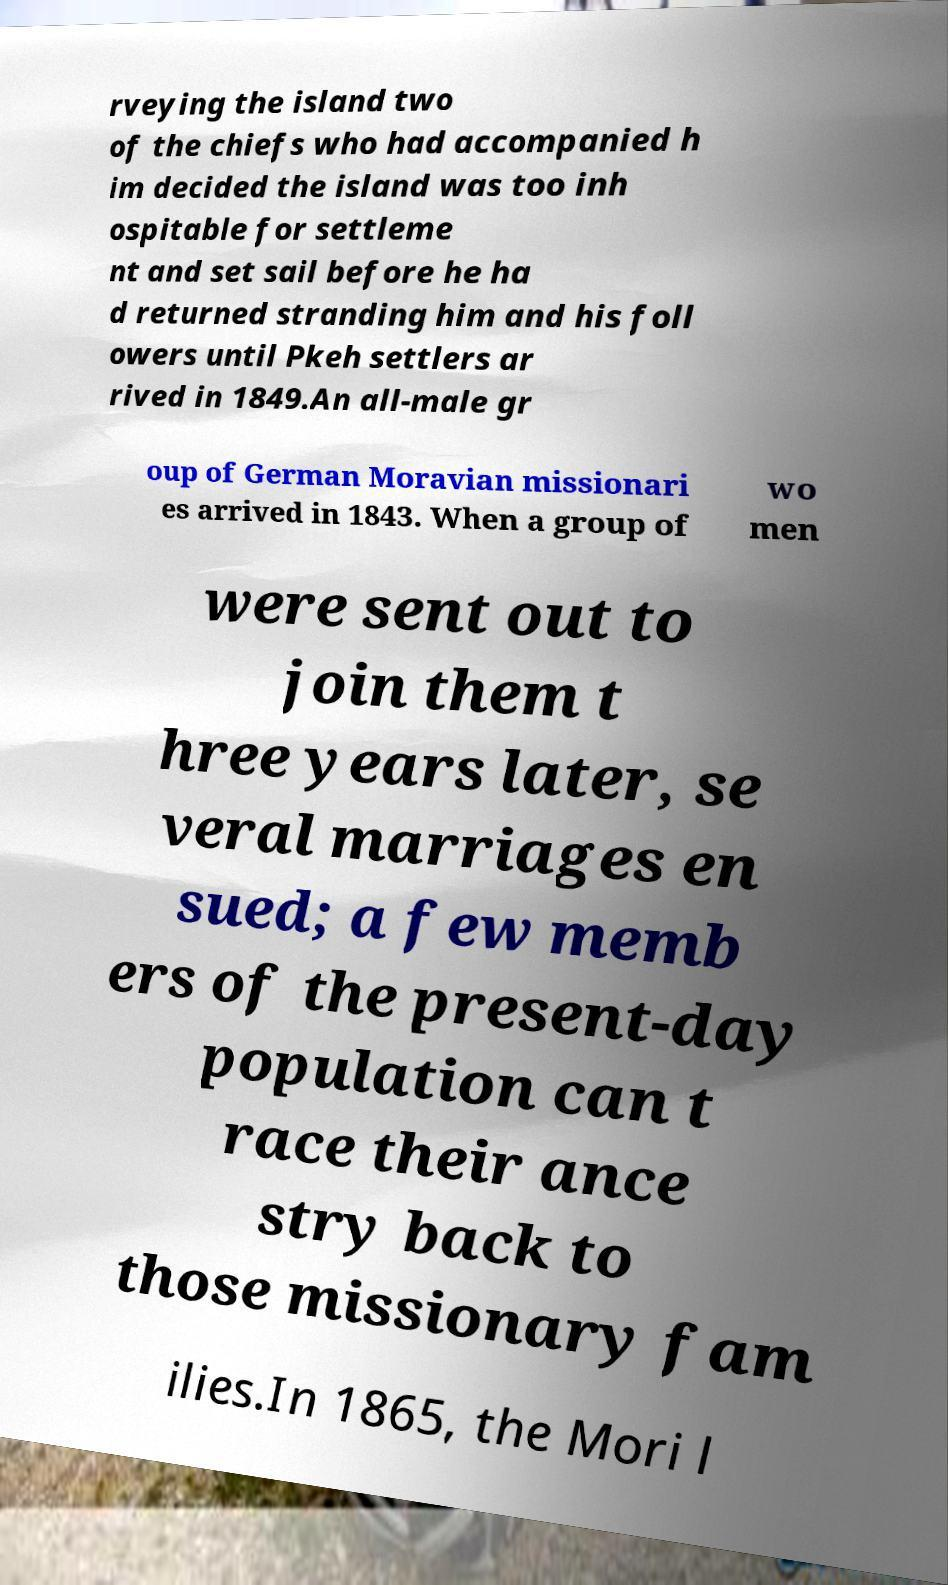Please read and relay the text visible in this image. What does it say? rveying the island two of the chiefs who had accompanied h im decided the island was too inh ospitable for settleme nt and set sail before he ha d returned stranding him and his foll owers until Pkeh settlers ar rived in 1849.An all-male gr oup of German Moravian missionari es arrived in 1843. When a group of wo men were sent out to join them t hree years later, se veral marriages en sued; a few memb ers of the present-day population can t race their ance stry back to those missionary fam ilies.In 1865, the Mori l 